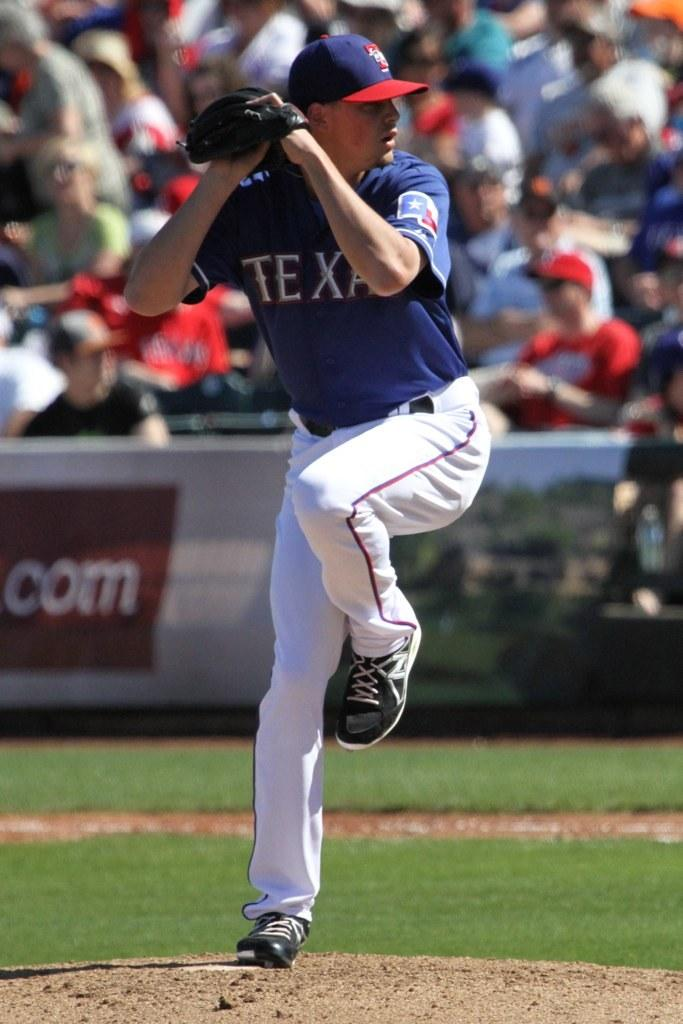<image>
Summarize the visual content of the image. Baseball pitcher from the team Texas ready to throw the ball. 